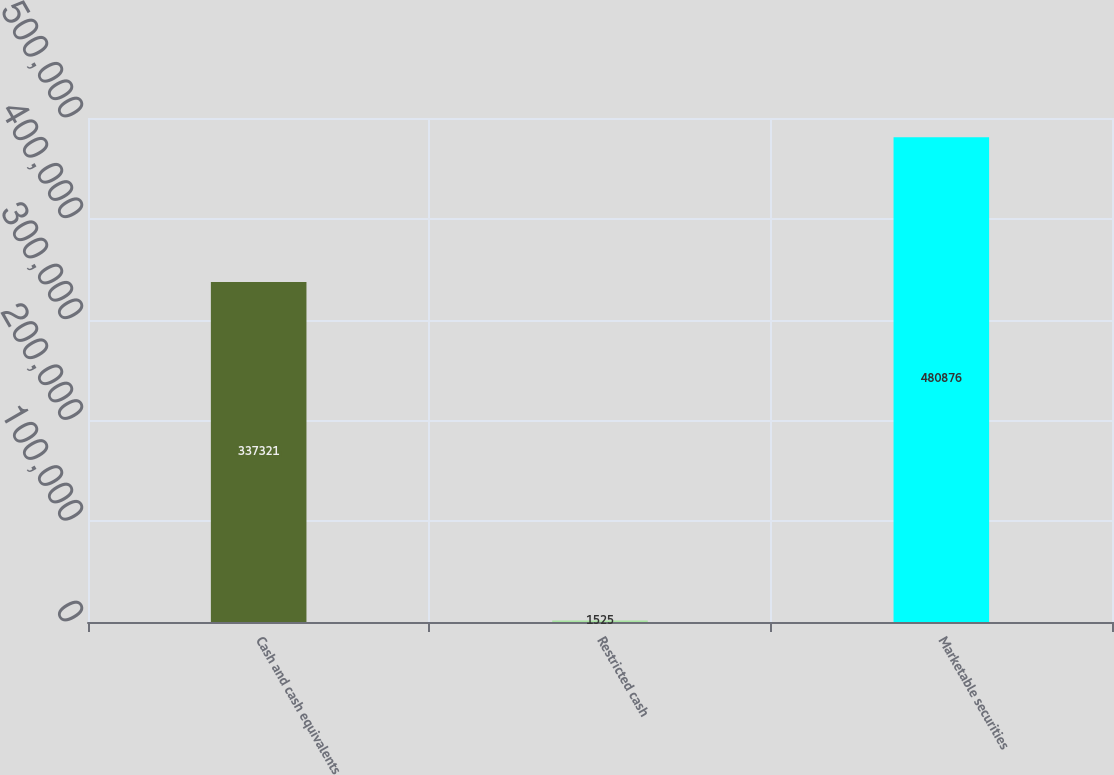Convert chart to OTSL. <chart><loc_0><loc_0><loc_500><loc_500><bar_chart><fcel>Cash and cash equivalents<fcel>Restricted cash<fcel>Marketable securities<nl><fcel>337321<fcel>1525<fcel>480876<nl></chart> 